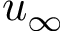<formula> <loc_0><loc_0><loc_500><loc_500>u _ { \infty }</formula> 